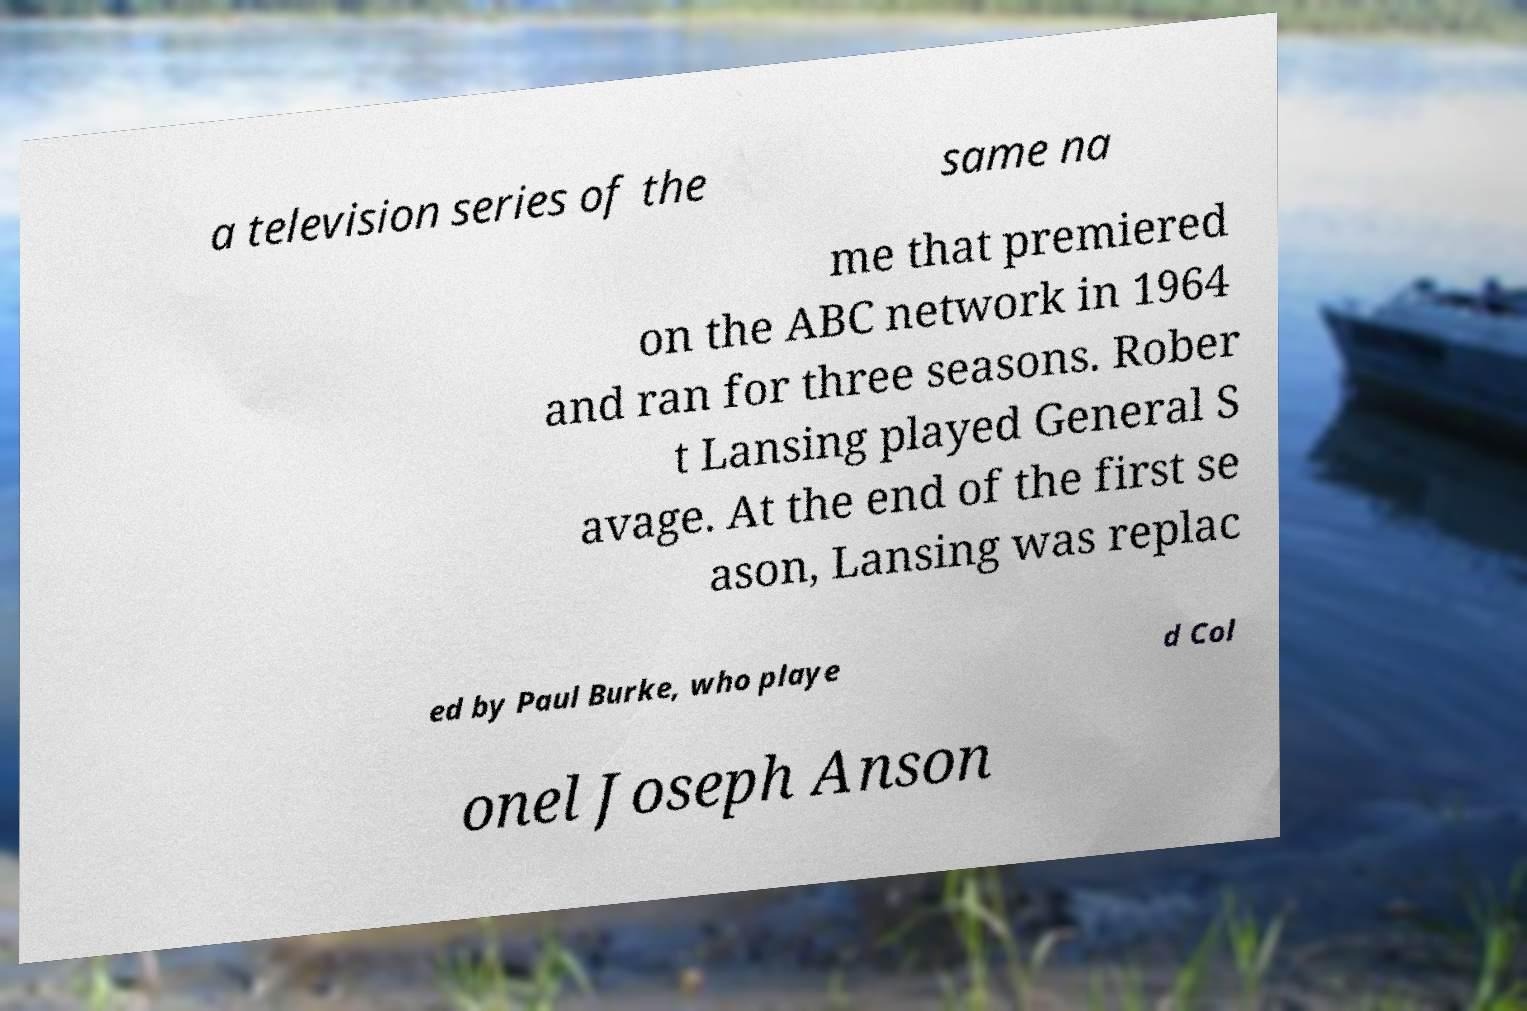Could you assist in decoding the text presented in this image and type it out clearly? a television series of the same na me that premiered on the ABC network in 1964 and ran for three seasons. Rober t Lansing played General S avage. At the end of the first se ason, Lansing was replac ed by Paul Burke, who playe d Col onel Joseph Anson 